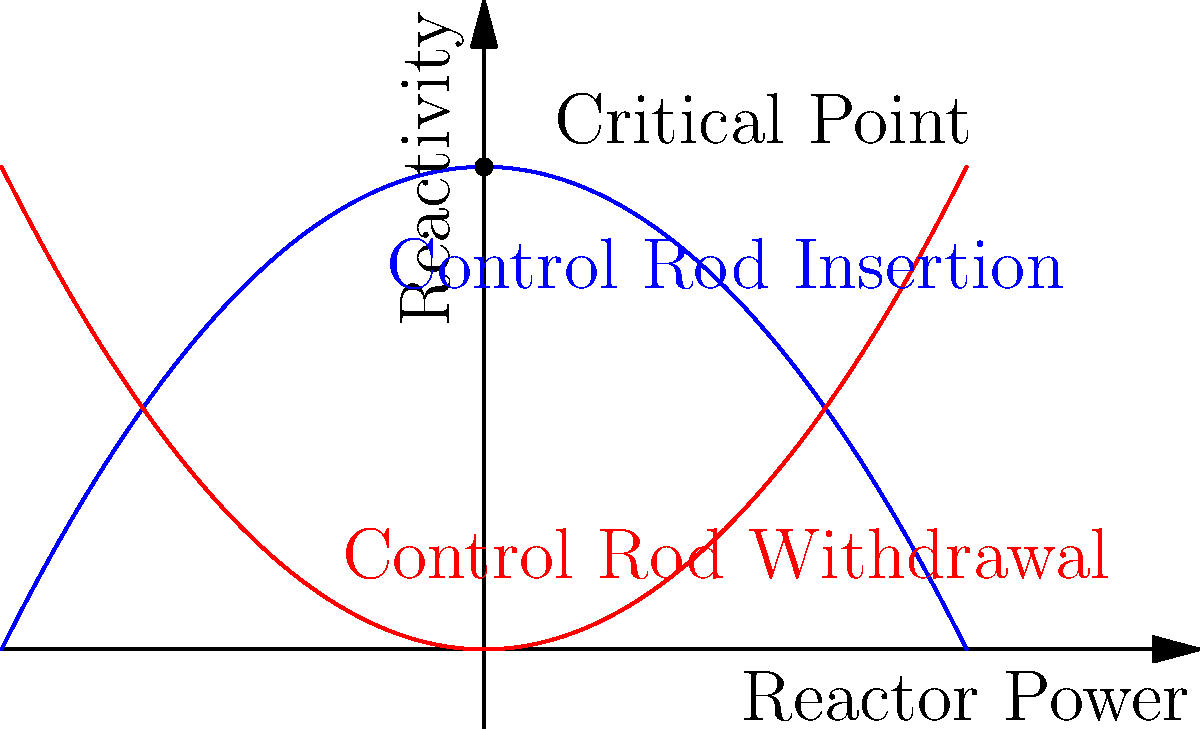Based on the graph showing the relationship between reactor power and reactivity during control rod insertion and withdrawal, what is the significance of the point where the two curves intersect, and how does it relate to reactor criticality? To understand the significance of the intersection point and its relation to reactor criticality, let's analyze the graph step-by-step:

1. The blue curve represents control rod insertion, while the red curve represents control rod withdrawal.

2. The x-axis represents reactor power, and the y-axis represents reactivity.

3. The point where the two curves intersect is labeled as the "Critical Point."

4. At this point:
   a) The reactivity is zero (y-coordinate is 0).
   b) The reactor power is at a specific stable level (x-coordinate of the intersection).

5. In reactor physics:
   a) When reactivity = 0, the reactor is critical.
   b) Critical state means the neutron population remains constant over time.

6. The significance of this point:
   a) It represents the equilibrium state of the reactor.
   b) The rate of neutron production equals the rate of neutron loss.
   c) The reactor power remains constant at this point.

7. Relation to reactor criticality:
   a) Above this point (during rod withdrawal), the reactor is supercritical (reactivity > 0).
   b) Below this point (during rod insertion), the reactor is subcritical (reactivity < 0).

8. The critical point is crucial for maintaining stable reactor operation and power control.

Therefore, the intersection point represents the critical state of the reactor, where the power level is stable, and the reactor is neither increasing nor decreasing in power output.
Answer: The intersection point represents the critical state where reactivity is zero and reactor power is stable. 